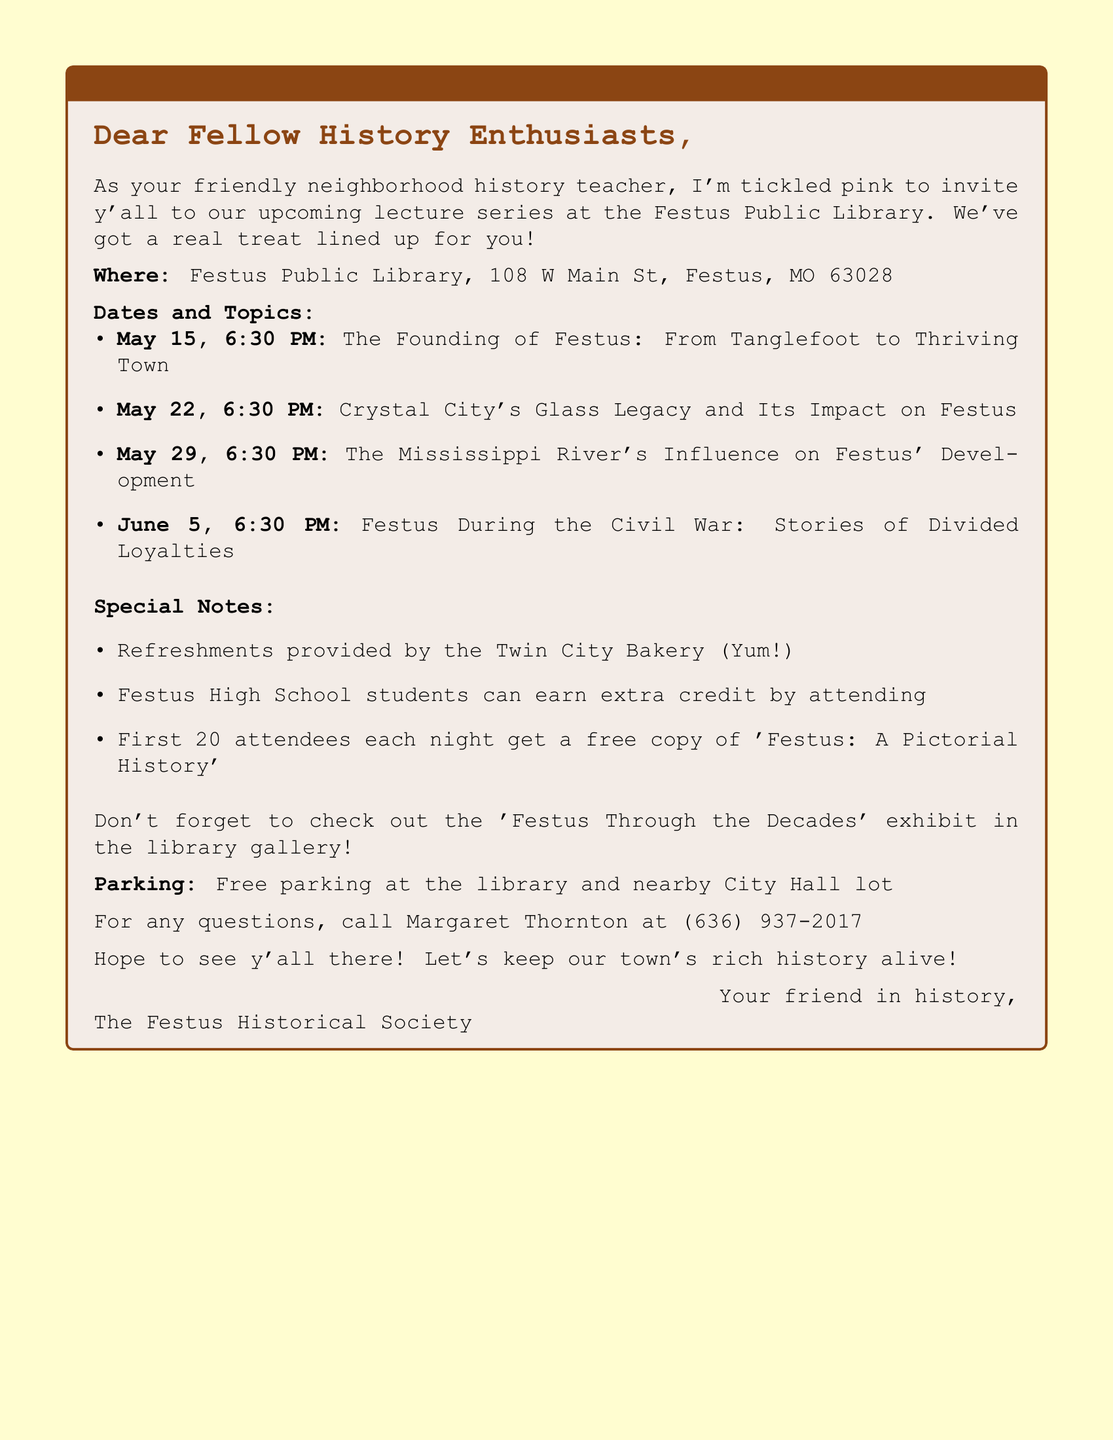What is the venue for the lecture series? The venue is specifically named in the document as the Festus Public Library.
Answer: Festus Public Library Who is the contact person for inquiries? The document identifies Margaret Thornton as the contact person for the event.
Answer: Margaret Thornton How many lectures are scheduled in this series? The number of lectures can be counted in the document, which lists four distinct dates/topics.
Answer: Four What time do the lectures begin? The document consistently mentions the starting time as 6:30 PM for each lecture.
Answer: 6:30 PM What is the topic of the lecture on May 22? The document specifically lists this date along with its corresponding topic.
Answer: Crystal City's Glass Legacy and Its Impact on Festus What type of refreshments will be provided? The document states that refreshments are from a specific local bakery.
Answer: Twin City Bakery What happens for Festus High School students attending the lectures? The document mentions a specific academic benefit for students who attend the lectures.
Answer: Extra credit Where can you find the related exhibit during the lecture series? The document names the location of the exhibit mentioned in relation to the lecture series.
Answer: Festus Public Library Gallery Is the library accessible for wheelchair users? The document includes an accessibility note for the library.
Answer: Yes 